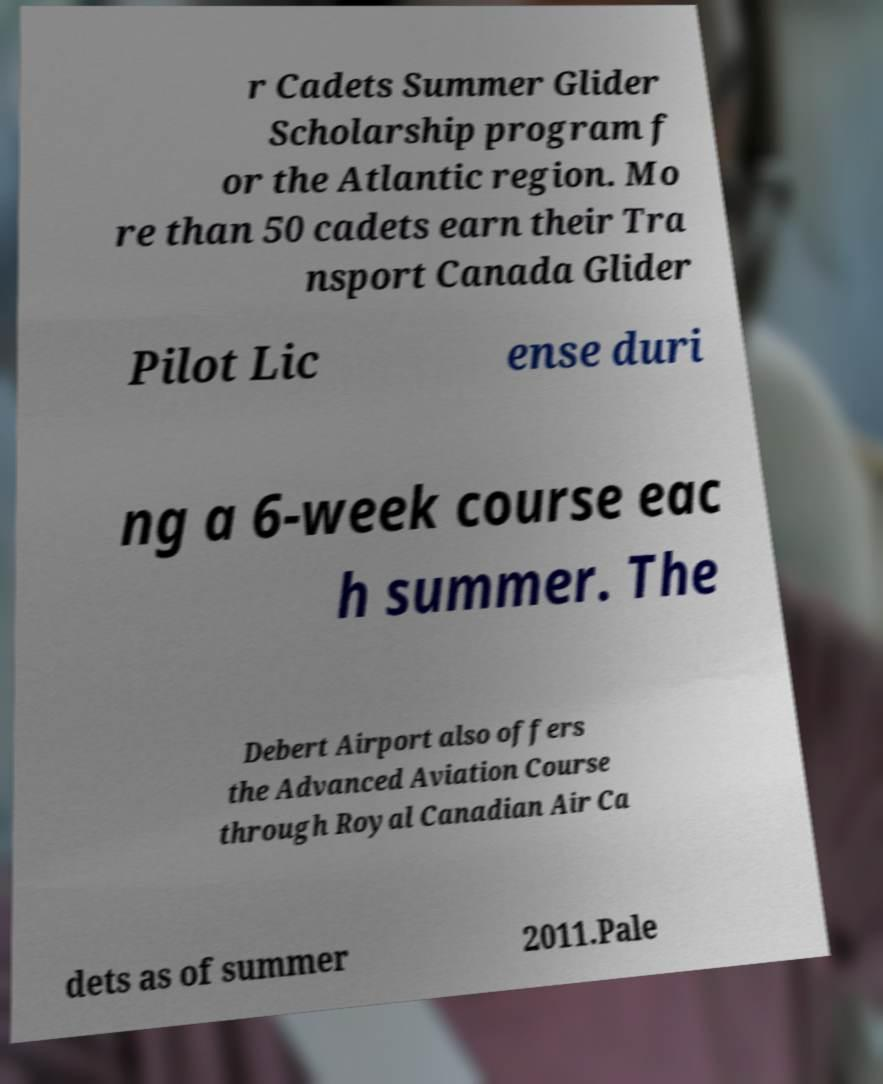Can you read and provide the text displayed in the image?This photo seems to have some interesting text. Can you extract and type it out for me? r Cadets Summer Glider Scholarship program f or the Atlantic region. Mo re than 50 cadets earn their Tra nsport Canada Glider Pilot Lic ense duri ng a 6-week course eac h summer. The Debert Airport also offers the Advanced Aviation Course through Royal Canadian Air Ca dets as of summer 2011.Pale 